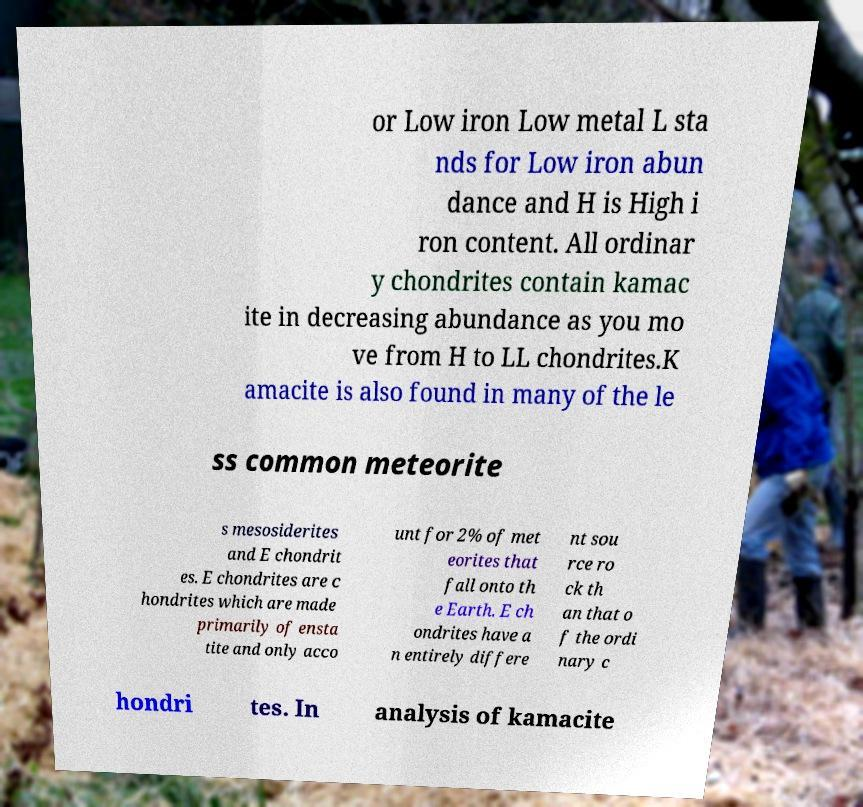Can you accurately transcribe the text from the provided image for me? or Low iron Low metal L sta nds for Low iron abun dance and H is High i ron content. All ordinar y chondrites contain kamac ite in decreasing abundance as you mo ve from H to LL chondrites.K amacite is also found in many of the le ss common meteorite s mesosiderites and E chondrit es. E chondrites are c hondrites which are made primarily of ensta tite and only acco unt for 2% of met eorites that fall onto th e Earth. E ch ondrites have a n entirely differe nt sou rce ro ck th an that o f the ordi nary c hondri tes. In analysis of kamacite 